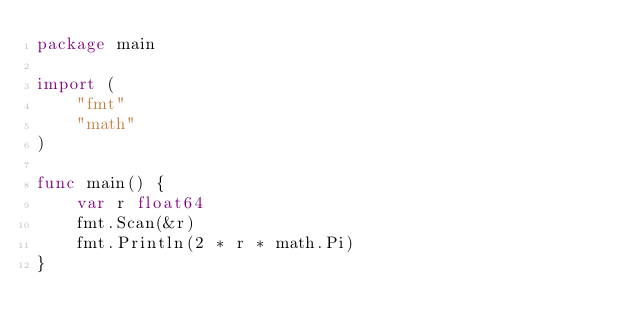<code> <loc_0><loc_0><loc_500><loc_500><_Go_>package main

import (
	"fmt"
	"math"
)

func main() {
	var r float64
	fmt.Scan(&r)
	fmt.Println(2 * r * math.Pi)
}</code> 